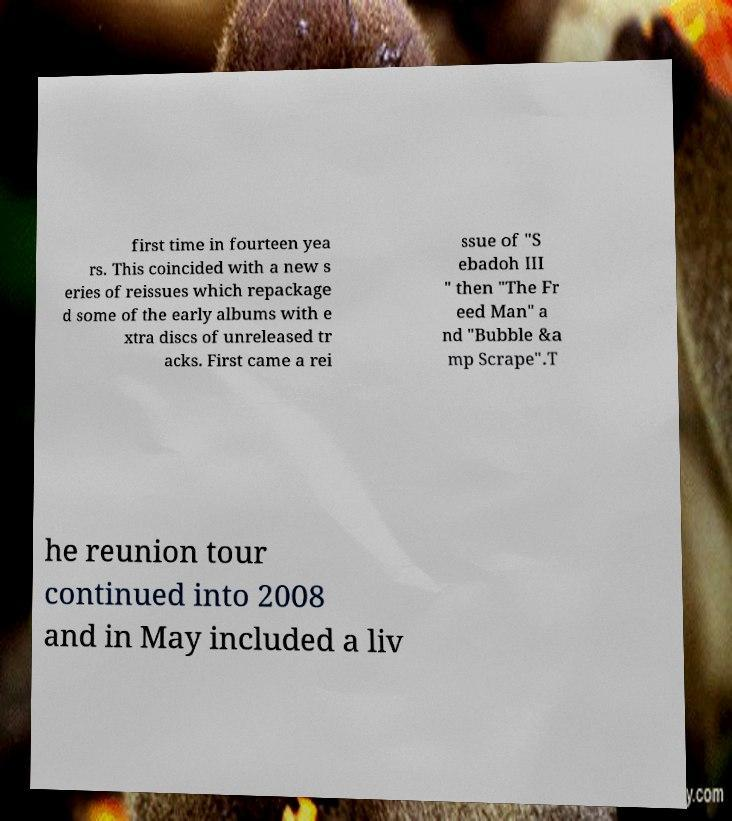What messages or text are displayed in this image? I need them in a readable, typed format. first time in fourteen yea rs. This coincided with a new s eries of reissues which repackage d some of the early albums with e xtra discs of unreleased tr acks. First came a rei ssue of "S ebadoh III " then "The Fr eed Man" a nd "Bubble &a mp Scrape".T he reunion tour continued into 2008 and in May included a liv 